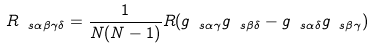Convert formula to latex. <formula><loc_0><loc_0><loc_500><loc_500>R _ { \ s \alpha \beta \gamma \delta } = \frac { 1 } { N ( N - 1 ) } R ( g _ { \ s \alpha \gamma } g _ { \ s \beta \delta } - g _ { \ s \alpha \delta } g _ { \ s \beta \gamma } )</formula> 